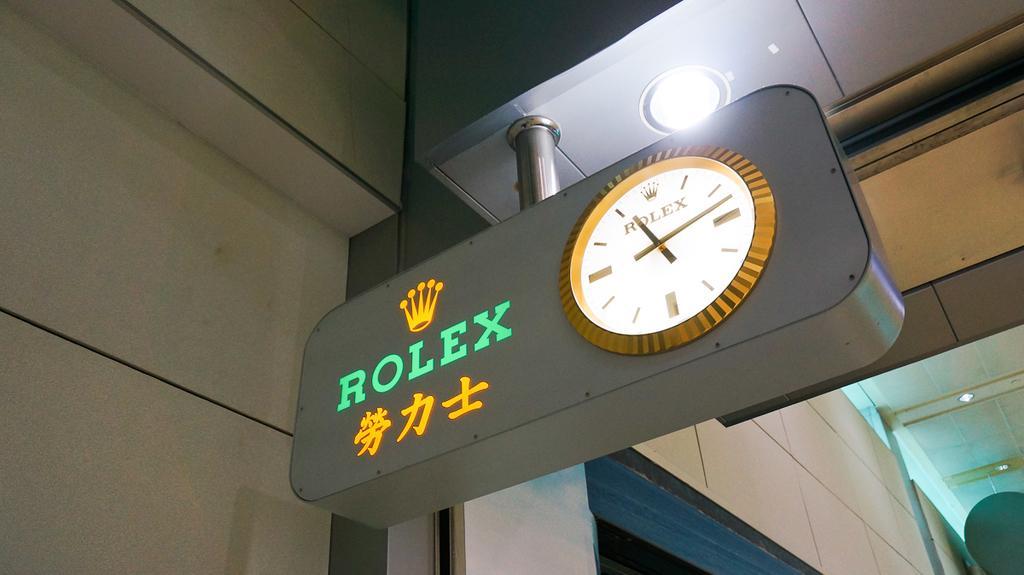Describe this image in one or two sentences. In this picture I can see a board with a clock and text on it, at the top there is a light. 